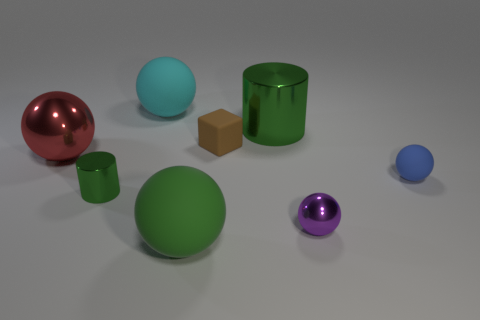Is the number of cubes that are on the left side of the tiny purple metal sphere greater than the number of green cylinders that are in front of the small cylinder?
Offer a terse response. Yes. There is a metal cylinder that is the same size as the cyan ball; what color is it?
Provide a succinct answer. Green. Are there any blocks that have the same color as the tiny cylinder?
Offer a terse response. No. Is the color of the small rubber thing that is right of the tiny brown cube the same as the large metallic thing that is left of the green rubber thing?
Your answer should be compact. No. What is the tiny ball in front of the small rubber ball made of?
Offer a terse response. Metal. The other big object that is made of the same material as the cyan thing is what color?
Make the answer very short. Green. What number of purple shiny objects are the same size as the red object?
Give a very brief answer. 0. There is a cylinder left of the brown rubber thing; is it the same size as the tiny purple object?
Your answer should be compact. Yes. There is a green object that is in front of the small block and behind the small purple shiny ball; what shape is it?
Ensure brevity in your answer.  Cylinder. There is a tiny metal sphere; are there any small brown cubes on the right side of it?
Offer a terse response. No. 